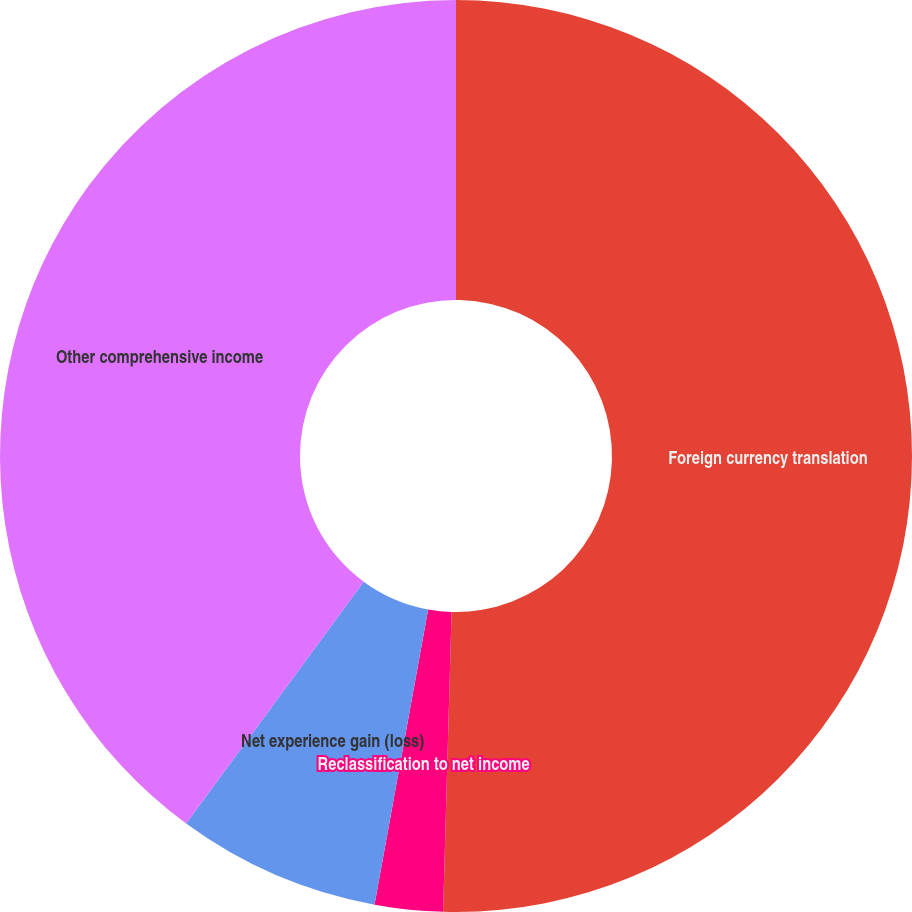Convert chart. <chart><loc_0><loc_0><loc_500><loc_500><pie_chart><fcel>Foreign currency translation<fcel>Reclassification to net income<fcel>Net experience gain (loss)<fcel>Other comprehensive income<nl><fcel>50.45%<fcel>2.41%<fcel>7.22%<fcel>39.92%<nl></chart> 